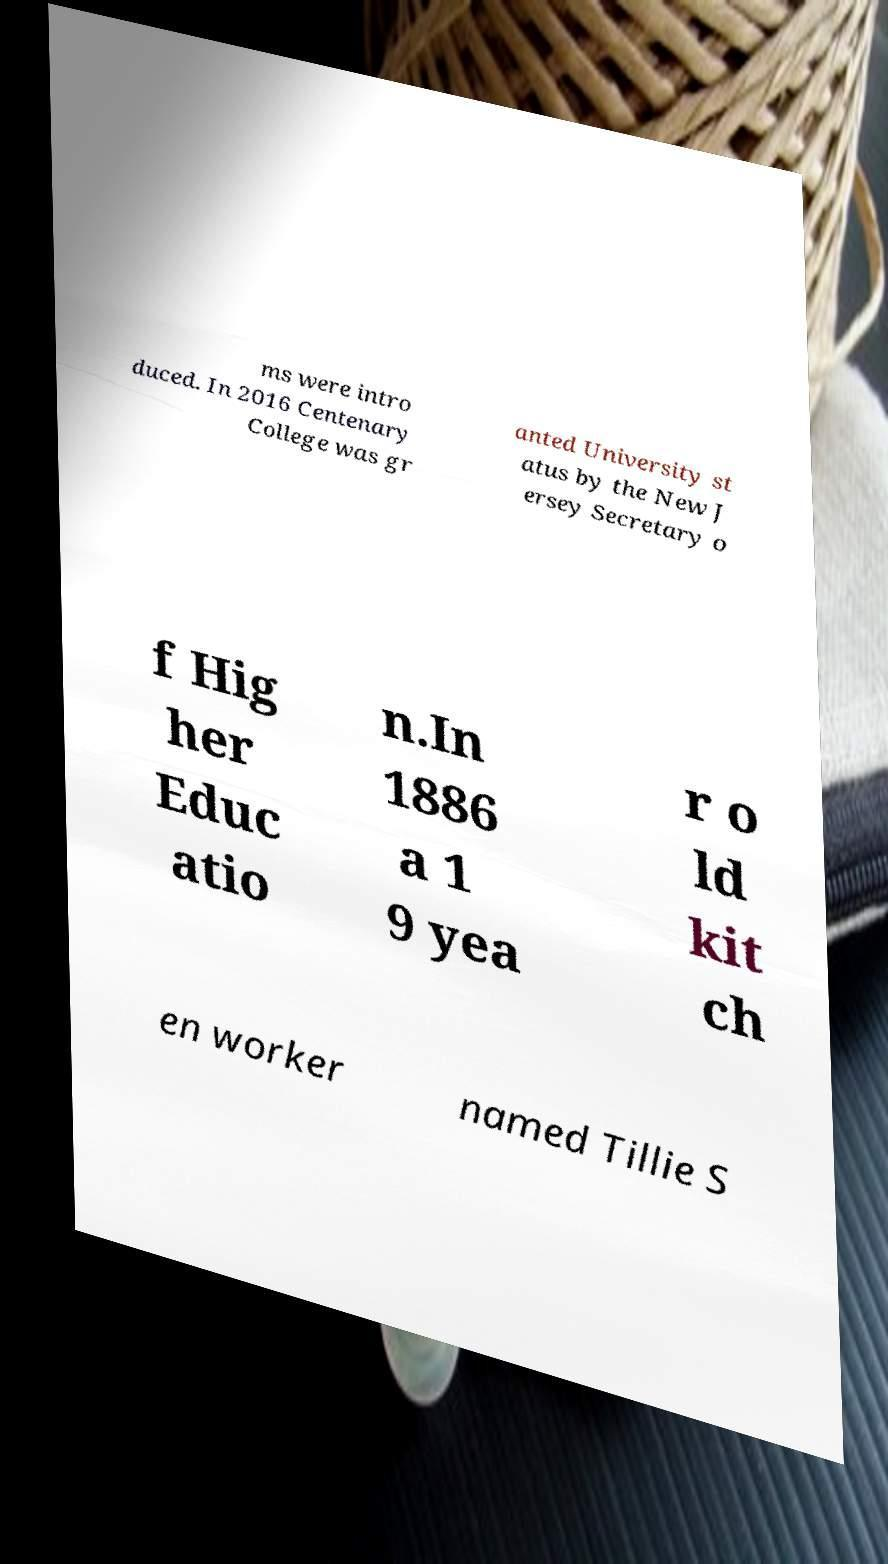Please identify and transcribe the text found in this image. ms were intro duced. In 2016 Centenary College was gr anted University st atus by the New J ersey Secretary o f Hig her Educ atio n.In 1886 a 1 9 yea r o ld kit ch en worker named Tillie S 